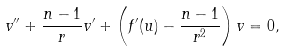<formula> <loc_0><loc_0><loc_500><loc_500>v ^ { \prime \prime } + \frac { n - 1 } { r } v ^ { \prime } + \left ( f ^ { \prime } ( u ) - \frac { n - 1 } { r ^ { 2 } } \right ) v = 0 ,</formula> 